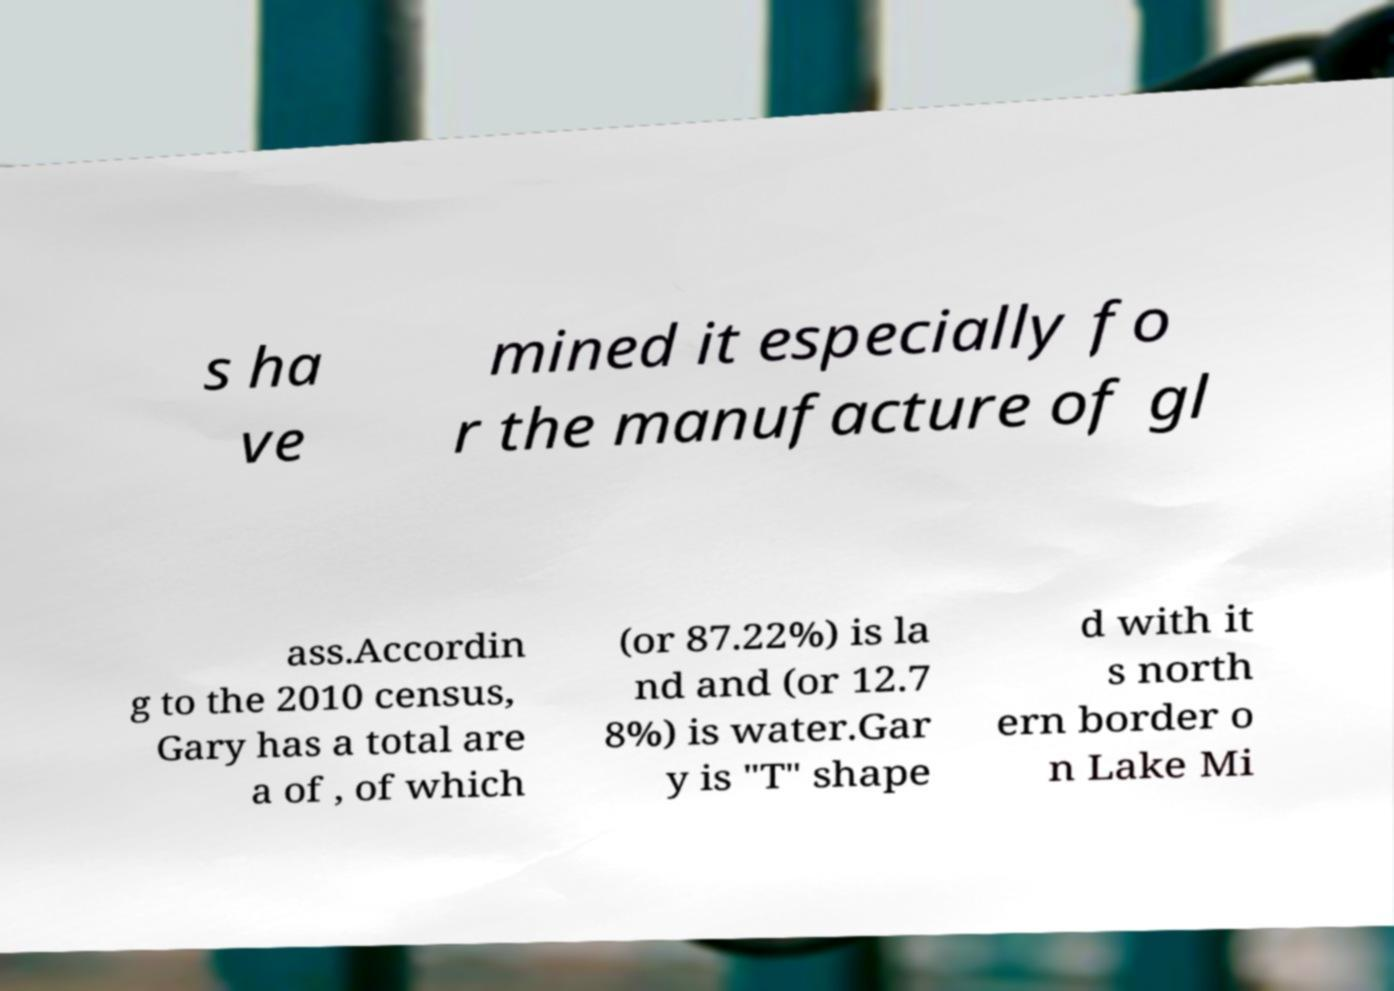Could you assist in decoding the text presented in this image and type it out clearly? s ha ve mined it especially fo r the manufacture of gl ass.Accordin g to the 2010 census, Gary has a total are a of , of which (or 87.22%) is la nd and (or 12.7 8%) is water.Gar y is "T" shape d with it s north ern border o n Lake Mi 